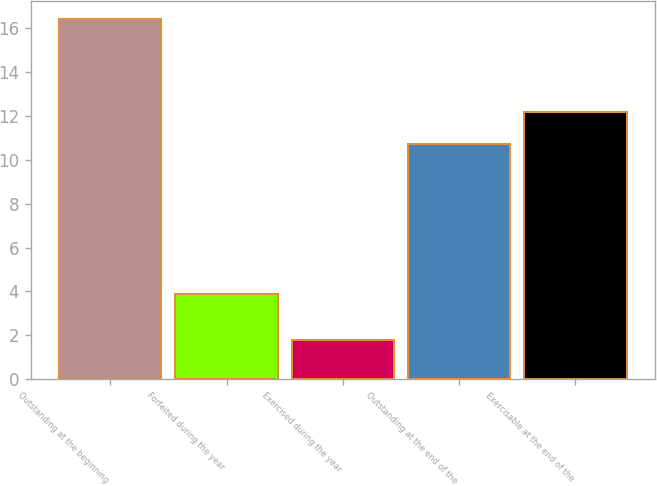Convert chart. <chart><loc_0><loc_0><loc_500><loc_500><bar_chart><fcel>Outstanding at the beginning<fcel>Forfeited during the year<fcel>Exercised during the year<fcel>Outstanding at the end of the<fcel>Exercisable at the end of the<nl><fcel>16.4<fcel>3.9<fcel>1.8<fcel>10.7<fcel>12.16<nl></chart> 